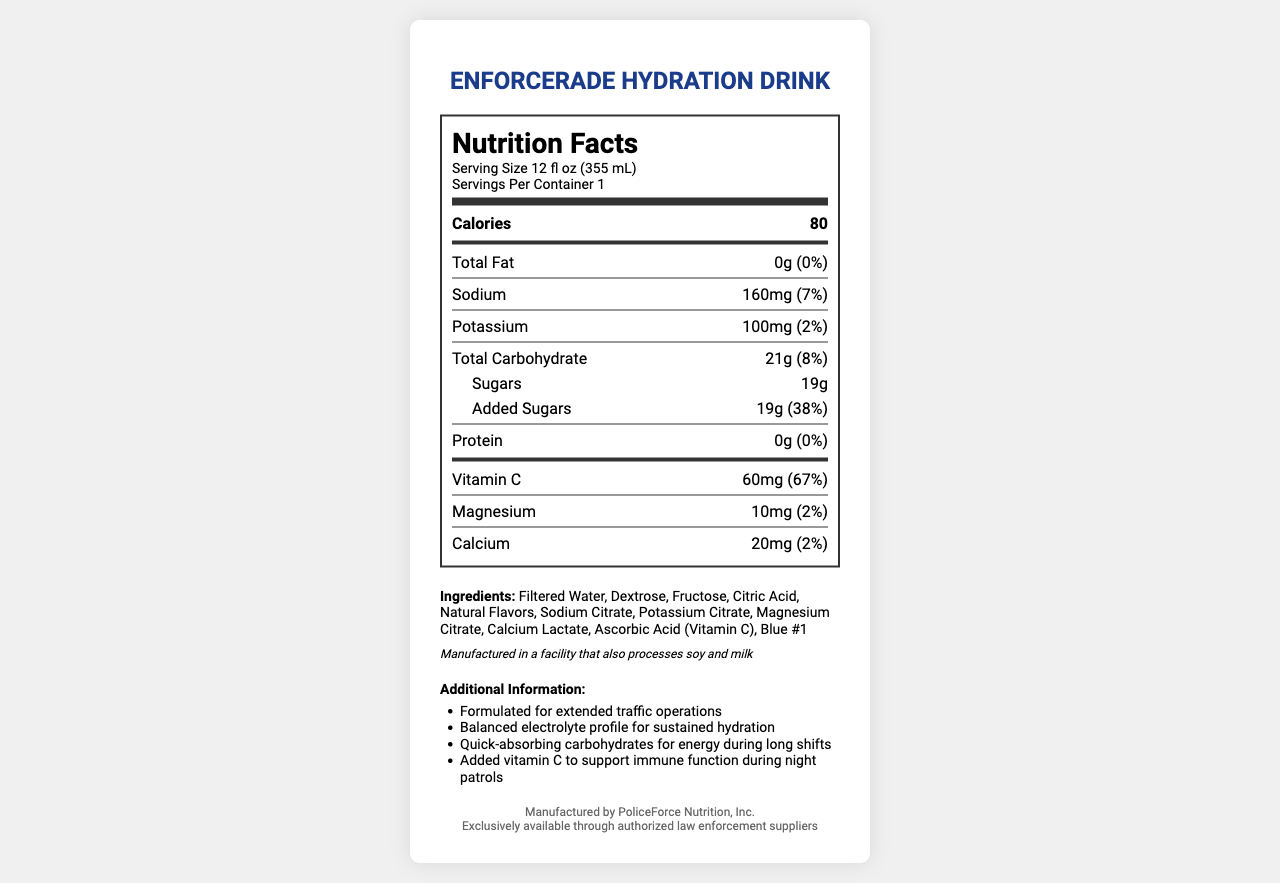what is the serving size of EnforcerAde Hydration Drink? The serving size is mentioned at the top of the nutrition label.
Answer: 12 fl oz (355 mL) how many calories are in a single serving? The calories per serving are listed prominently in the nutrition information section.
Answer: 80 what is the amount of sodium per serving? The sodium content is mentioned under the nutrition facts, next to the ingredient sodium.
Answer: 160mg how much added sugar does one serving contain? The added sugar amount is listed under the sugars section, indicating both the quantity and daily value percentage.
Answer: 19g how much vitamin C is in one serving? The amount of vitamin C and its daily value percentage are given in the nutrition facts.
Answer: 60mg which company manufactures EnforcerAde Hydration Drink? The manufacturer is specified at the bottom of the document.
Answer: PoliceForce Nutrition, Inc. what is the percentage of daily value for carbohydrates? The daily value percentage for total carbohydrates is listed next to its amount.
Answer: 8% what are the main electrolytes present in this drink? A) Sodium and Potassium B) Calcium and Magnesium C) Both A and B D) None of the above Sodium, Potassium, Calcium, and Magnesium are mentioned in the nutrition facts as electrolytes.
Answer: C) Both A and B EnforcerAde contains 100mg of which mineral? 1) Sodium 2) Potassium 3) Calcium 4) Magnesium The amount of Potassium per serving is specified as 100mg.
Answer: 2) Potassium is there any protein in EnforcerAde Hydration Drink? The protein amount is listed as 0g in the nutrition facts.
Answer: No does the drink contain any fat? The total fat is listed as 0g in the nutrition facts section.
Answer: No what colors are used in this product? The list of ingredients includes Blue #1 as the coloring agent.
Answer: Blue #1 what information is provided about allergens? The allergen information is stated below the ingredients list.
Answer: Manufactured in a facility that also processes soy and milk how many kinds of sugars are used in this drink? The ingredients list shows two sugars: Dextrose and Fructose.
Answer: Two what type of hydration is EnforcerAde formulated for? This is highlighted under the additional information section.
Answer: Extended traffic operations summarize the nutritional benefits of EnforcerAde Hydration Drink. This summary is derived from the additional information and nutrition facts that highlight the formulated benefits.
Answer: EnforcerAde Hydration Drink offers balanced electrolytes for sustained hydration, quick-absorbing carbohydrates for energy, and added vitamin C to support immune function during long shifts, especially for police officers during extended traffic operations. does the drink contain any soy or milk? The allergen information states it is manufactured in a facility that processes soy and milk, but it does not confirm if the drink contains soy or milk.
Answer: Cannot be determined 